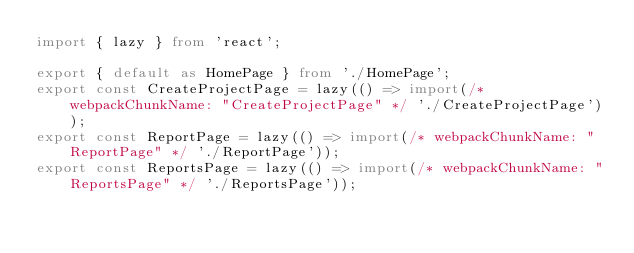Convert code to text. <code><loc_0><loc_0><loc_500><loc_500><_TypeScript_>import { lazy } from 'react';

export { default as HomePage } from './HomePage';
export const CreateProjectPage = lazy(() => import(/* webpackChunkName: "CreateProjectPage" */ './CreateProjectPage'));
export const ReportPage = lazy(() => import(/* webpackChunkName: "ReportPage" */ './ReportPage'));
export const ReportsPage = lazy(() => import(/* webpackChunkName: "ReportsPage" */ './ReportsPage'));
</code> 